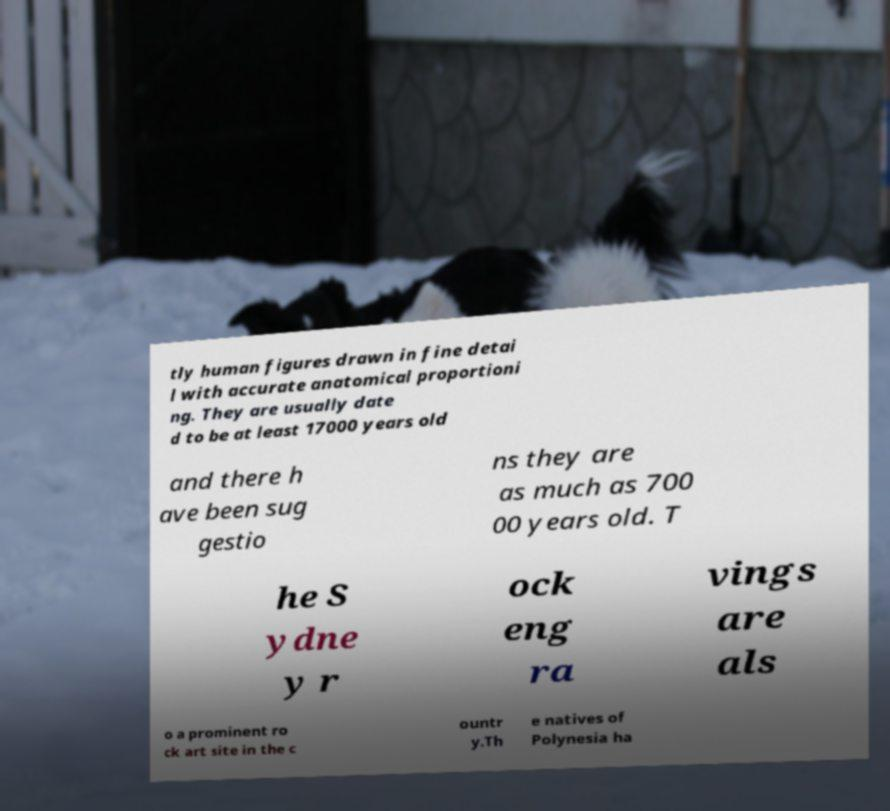I need the written content from this picture converted into text. Can you do that? tly human figures drawn in fine detai l with accurate anatomical proportioni ng. They are usually date d to be at least 17000 years old and there h ave been sug gestio ns they are as much as 700 00 years old. T he S ydne y r ock eng ra vings are als o a prominent ro ck art site in the c ountr y.Th e natives of Polynesia ha 